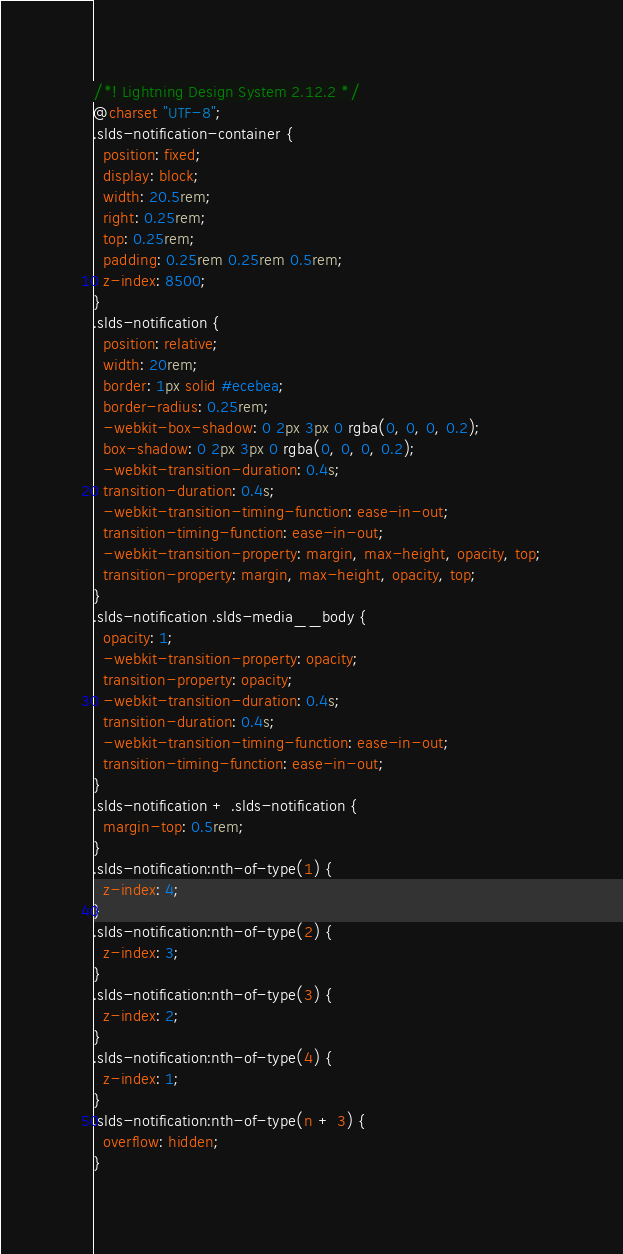Convert code to text. <code><loc_0><loc_0><loc_500><loc_500><_CSS_>/*! Lightning Design System 2.12.2 */
@charset "UTF-8";
.slds-notification-container {
  position: fixed;
  display: block;
  width: 20.5rem;
  right: 0.25rem;
  top: 0.25rem;
  padding: 0.25rem 0.25rem 0.5rem;
  z-index: 8500;
}
.slds-notification {
  position: relative;
  width: 20rem;
  border: 1px solid #ecebea;
  border-radius: 0.25rem;
  -webkit-box-shadow: 0 2px 3px 0 rgba(0, 0, 0, 0.2);
  box-shadow: 0 2px 3px 0 rgba(0, 0, 0, 0.2);
  -webkit-transition-duration: 0.4s;
  transition-duration: 0.4s;
  -webkit-transition-timing-function: ease-in-out;
  transition-timing-function: ease-in-out;
  -webkit-transition-property: margin, max-height, opacity, top;
  transition-property: margin, max-height, opacity, top;
}
.slds-notification .slds-media__body {
  opacity: 1;
  -webkit-transition-property: opacity;
  transition-property: opacity;
  -webkit-transition-duration: 0.4s;
  transition-duration: 0.4s;
  -webkit-transition-timing-function: ease-in-out;
  transition-timing-function: ease-in-out;
}
.slds-notification + .slds-notification {
  margin-top: 0.5rem;
}
.slds-notification:nth-of-type(1) {
  z-index: 4;
}
.slds-notification:nth-of-type(2) {
  z-index: 3;
}
.slds-notification:nth-of-type(3) {
  z-index: 2;
}
.slds-notification:nth-of-type(4) {
  z-index: 1;
}
.slds-notification:nth-of-type(n + 3) {
  overflow: hidden;
}</code> 